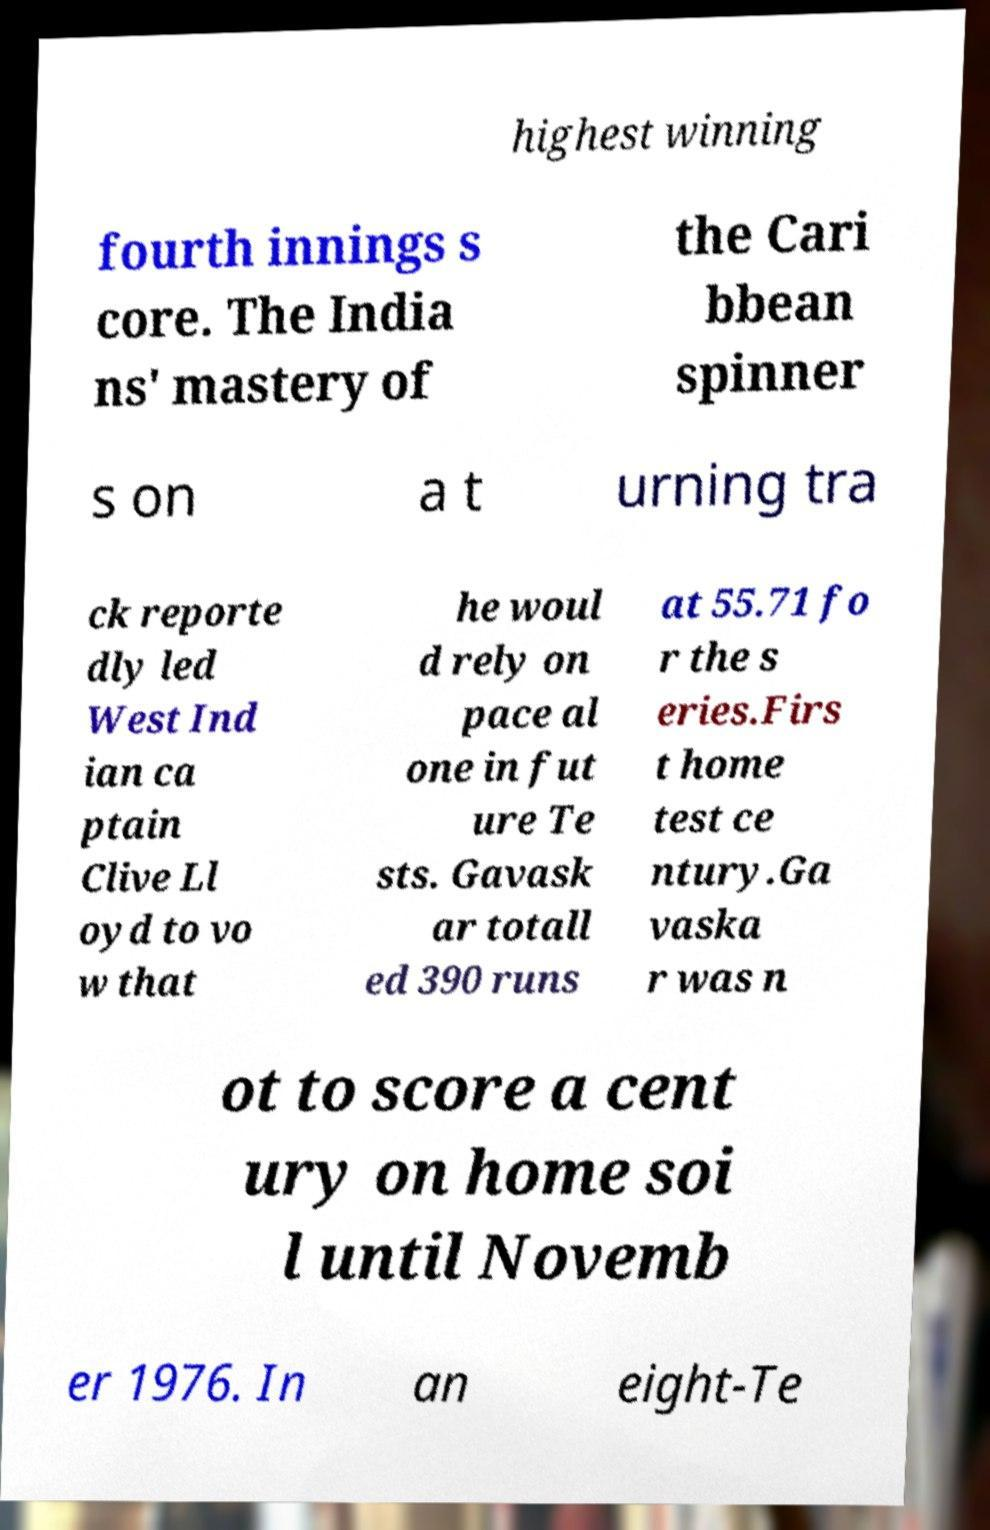Can you read and provide the text displayed in the image?This photo seems to have some interesting text. Can you extract and type it out for me? highest winning fourth innings s core. The India ns' mastery of the Cari bbean spinner s on a t urning tra ck reporte dly led West Ind ian ca ptain Clive Ll oyd to vo w that he woul d rely on pace al one in fut ure Te sts. Gavask ar totall ed 390 runs at 55.71 fo r the s eries.Firs t home test ce ntury.Ga vaska r was n ot to score a cent ury on home soi l until Novemb er 1976. In an eight-Te 